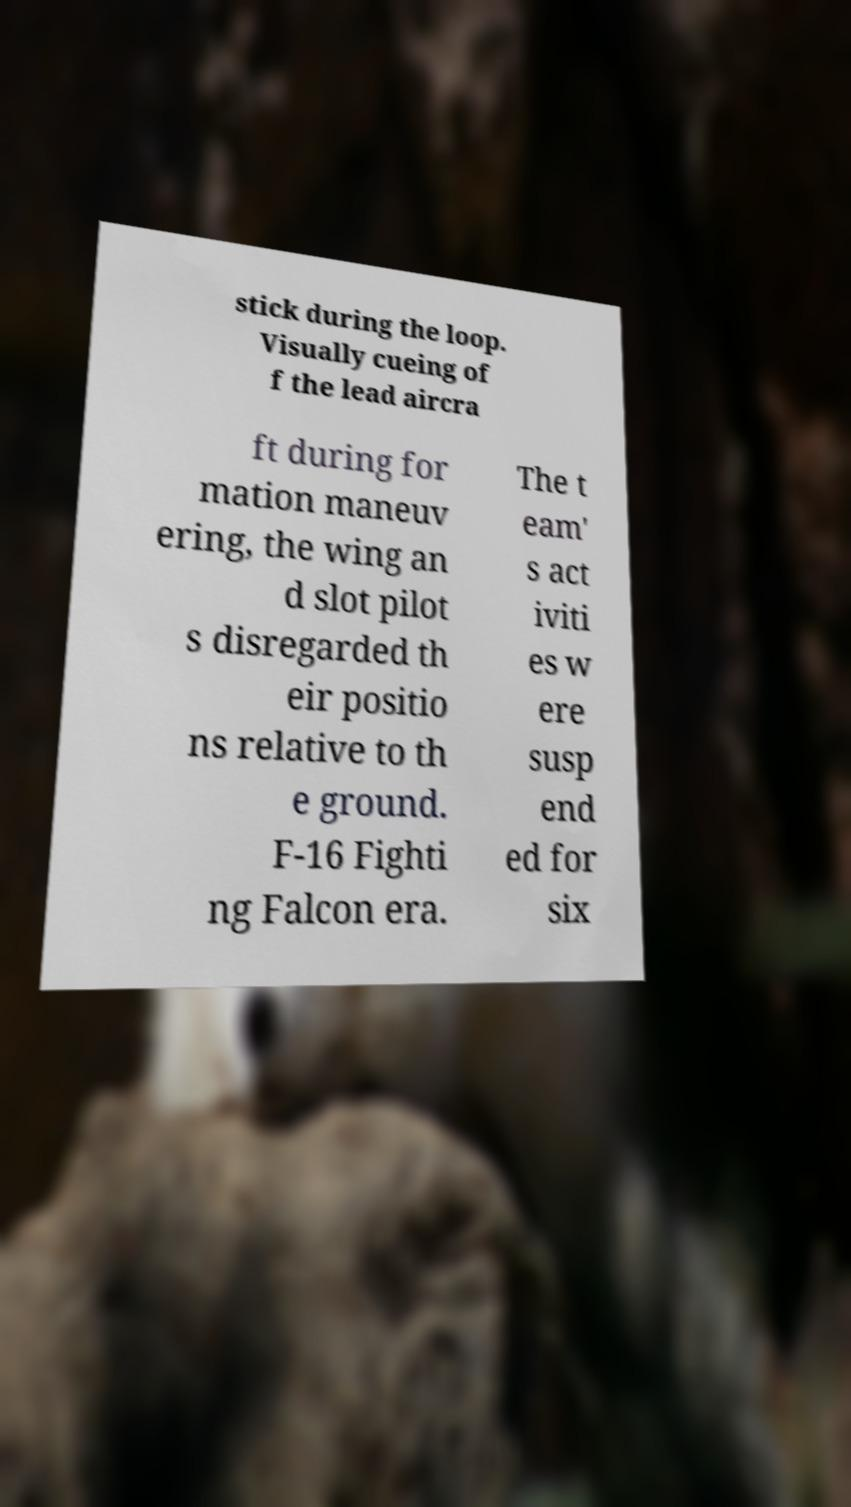Can you accurately transcribe the text from the provided image for me? stick during the loop. Visually cueing of f the lead aircra ft during for mation maneuv ering, the wing an d slot pilot s disregarded th eir positio ns relative to th e ground. F-16 Fighti ng Falcon era. The t eam' s act iviti es w ere susp end ed for six 